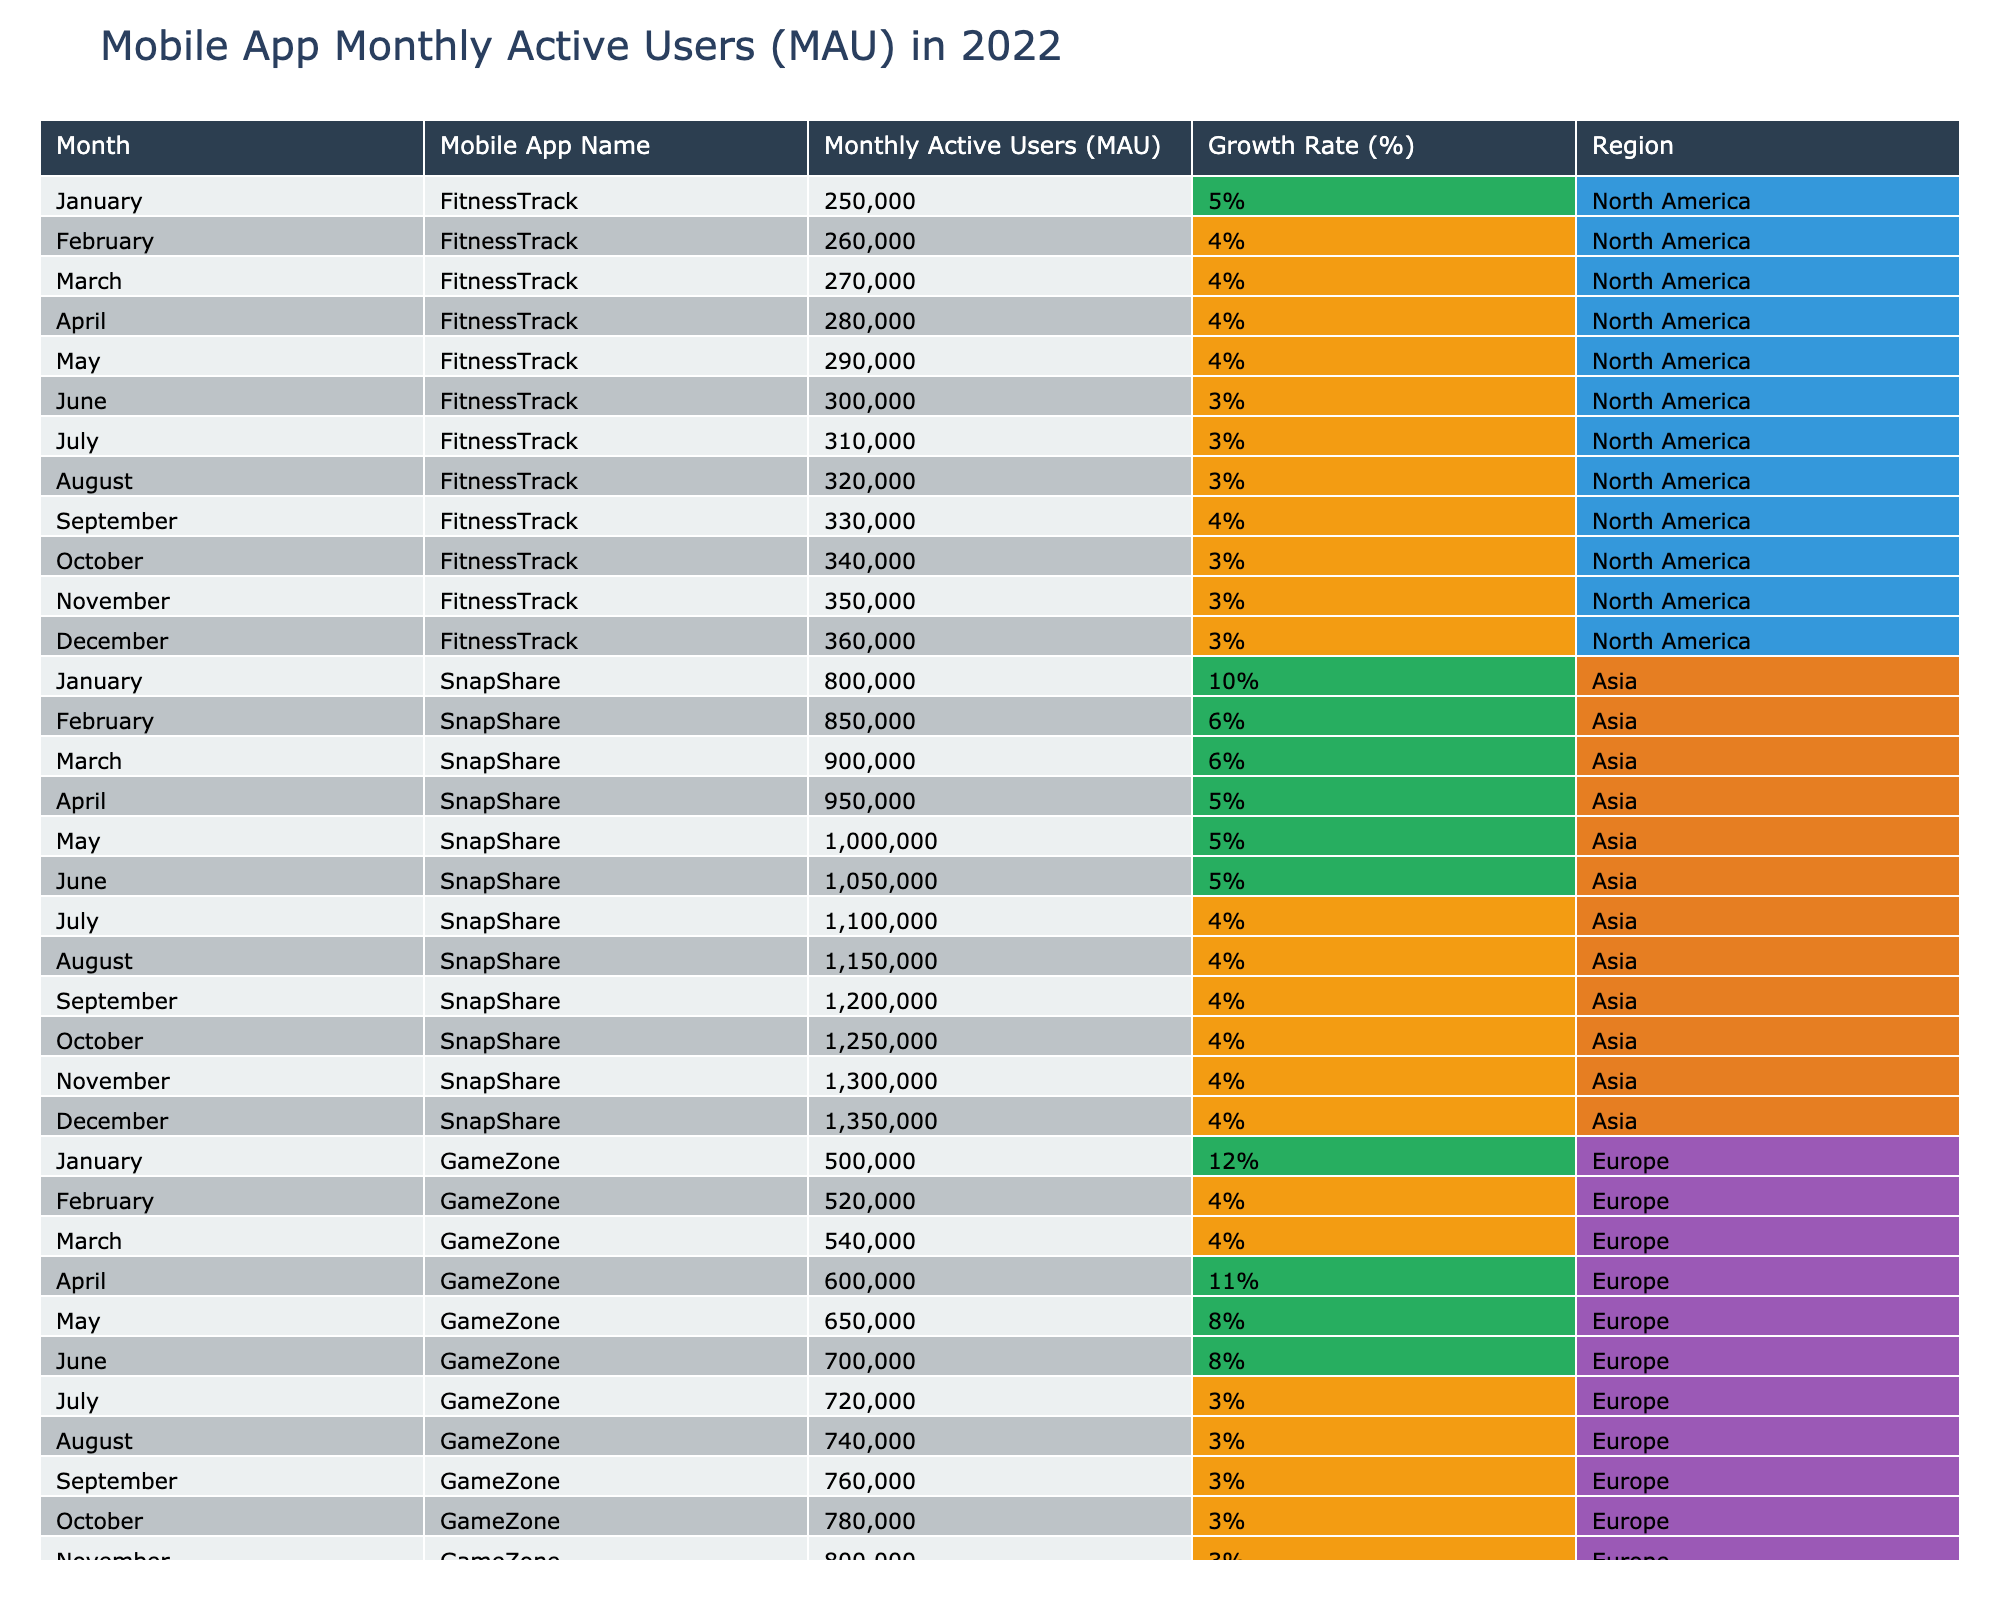What month had the highest Monthly Active Users (MAU) for FitnessTrack? By scanning the row corresponding to FitnessTrack, I see that December has the highest value at 360,000.
Answer: 360,000 Which mobile app had the largest Monthly Active Users (MAU) in July? Looking at the table, SnapShare has the highest MAU of 1,100,000 in July compared to the other apps.
Answer: 1,100,000 What was the Growth Rate for GameZone in April? Checking the row for GameZone in April, the Growth Rate is reported as 11%.
Answer: 11% Did ShopEase reach 600,000 Monthly Active Users (MAU) at any point during the year? Referring to the table, ShopEase reaches 560,000 in December, but does not reach 600,000.
Answer: No What was the average Monthly Active Users (MAU) for SnapShare over the entire year? Summing the values of MAU for SnapShare gives 800,000 + 850,000 + 900,000 + 950,000 + 1,000,000 + 1,050,000 + 1,100,000 + 1,150,000 + 1,200,000 + 1,250,000 + 1,300,000 + 1,350,000 = 13,800,000. Dividing by 12 gives an average of 1,150,000.
Answer: 1,150,000 Which app had the highest growth rate in February? In February, GameZone's growth rate is 4%, while FitnessTrack is 4% and SnapShare is 6%. Thus, SnapShare has the highest growth rate in February.
Answer: SnapShare Was there a month where GameZone's MAU increased by more than 10%? Analyzing the growth rates, GameZone increased by 12% in January and 11% in April, meaning there were indeed months with over 10% growth.
Answer: Yes What is the total Monthly Active Users (MAU) for all apps combined in December? MAU for December per app: FitnessTrack = 360,000, SnapShare = 1,350,000, GameZone = 820,000, ShopEase = 560,000. The total is 360,000 + 1,350,000 + 820,000 + 560,000 = 3,090,000.
Answer: 3,090,000 In which region was the app with the highest Monthly Active Users (MAU) located? SnapShare, with 1,350,000 MAU in December, is located in Asia, making it the app with the highest MAU.
Answer: Asia How many months did ShopEase maintain a growth rate below 3%? ShopEase had a consistent growth rate of 2% from February to December, which is a total of 11 months.
Answer: 11 months Was there a month where all apps had a growth rate of 5% or greater? Looking through all months, the only app that had a growth rate of 5% or greater during January is GameZone, which indicates that not all apps achieved this.
Answer: No 